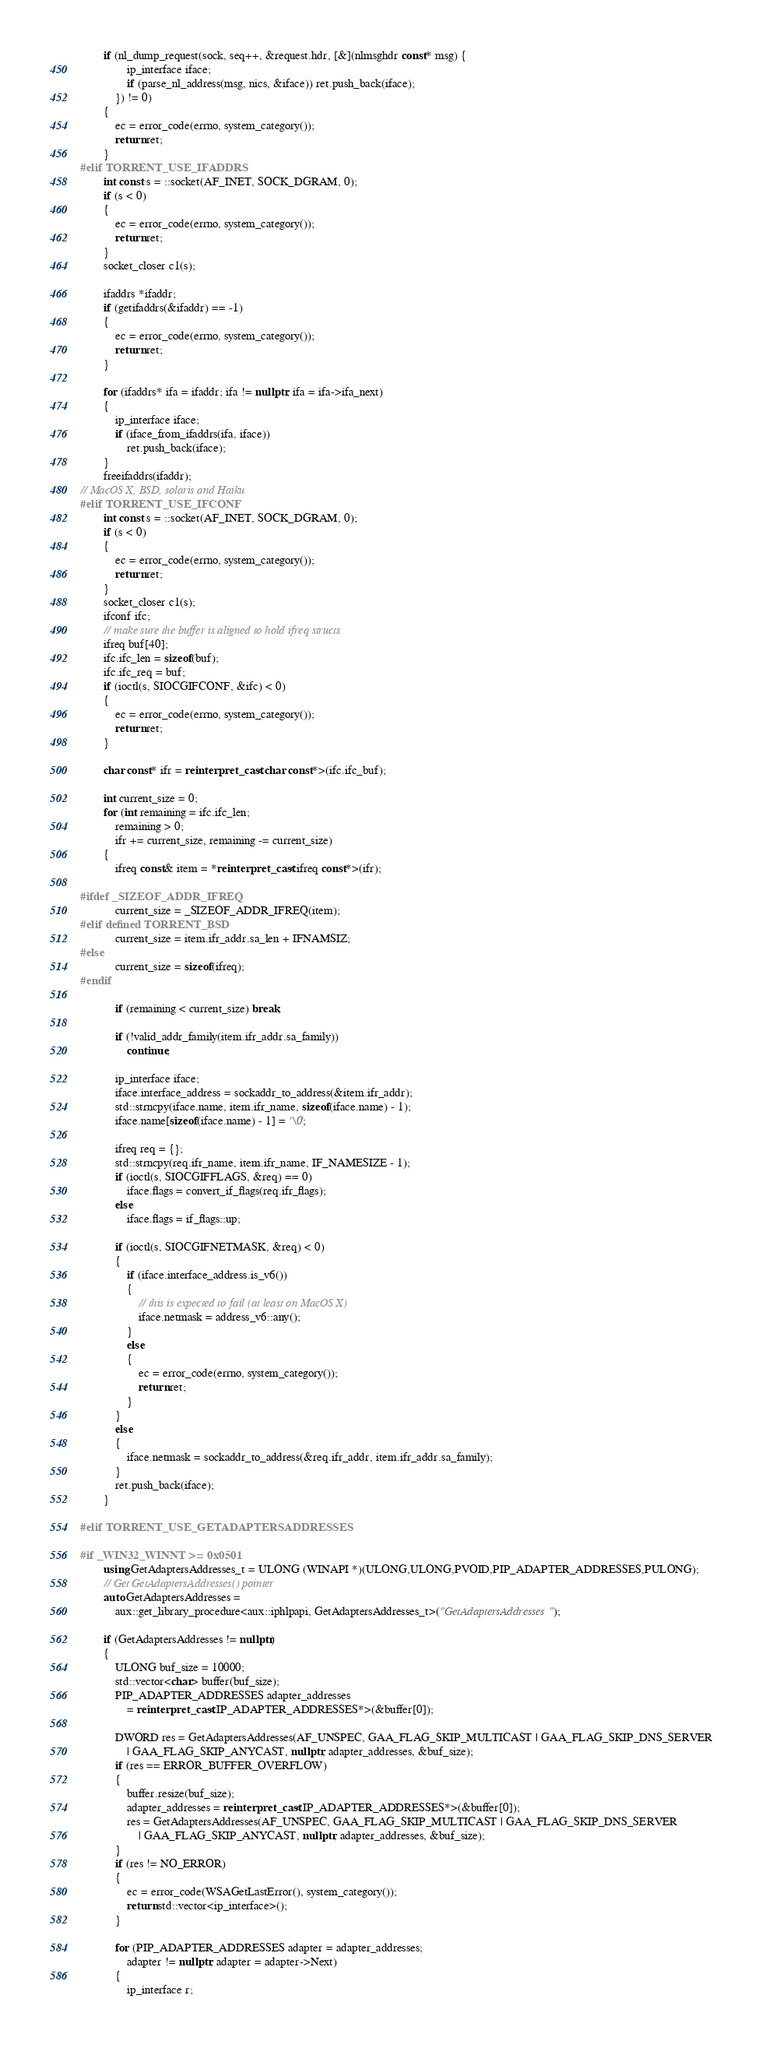Convert code to text. <code><loc_0><loc_0><loc_500><loc_500><_C++_>
		if (nl_dump_request(sock, seq++, &request.hdr, [&](nlmsghdr const* msg) {
				ip_interface iface;
				if (parse_nl_address(msg, nics, &iface)) ret.push_back(iface);
			}) != 0)
		{
			ec = error_code(errno, system_category());
			return ret;
		}
#elif TORRENT_USE_IFADDRS
		int const s = ::socket(AF_INET, SOCK_DGRAM, 0);
		if (s < 0)
		{
			ec = error_code(errno, system_category());
			return ret;
		}
		socket_closer c1(s);

		ifaddrs *ifaddr;
		if (getifaddrs(&ifaddr) == -1)
		{
			ec = error_code(errno, system_category());
			return ret;
		}

		for (ifaddrs* ifa = ifaddr; ifa != nullptr; ifa = ifa->ifa_next)
		{
			ip_interface iface;
			if (iface_from_ifaddrs(ifa, iface))
				ret.push_back(iface);
		}
		freeifaddrs(ifaddr);
// MacOS X, BSD, solaris and Haiku
#elif TORRENT_USE_IFCONF
		int const s = ::socket(AF_INET, SOCK_DGRAM, 0);
		if (s < 0)
		{
			ec = error_code(errno, system_category());
			return ret;
		}
		socket_closer c1(s);
		ifconf ifc;
		// make sure the buffer is aligned to hold ifreq structs
		ifreq buf[40];
		ifc.ifc_len = sizeof(buf);
		ifc.ifc_req = buf;
		if (ioctl(s, SIOCGIFCONF, &ifc) < 0)
		{
			ec = error_code(errno, system_category());
			return ret;
		}

		char const* ifr = reinterpret_cast<char const*>(ifc.ifc_buf);

		int current_size = 0;
		for (int remaining = ifc.ifc_len;
			remaining > 0;
			ifr += current_size, remaining -= current_size)
		{
			ifreq const& item = *reinterpret_cast<ifreq const*>(ifr);

#ifdef _SIZEOF_ADDR_IFREQ
			current_size = _SIZEOF_ADDR_IFREQ(item);
#elif defined TORRENT_BSD
			current_size = item.ifr_addr.sa_len + IFNAMSIZ;
#else
			current_size = sizeof(ifreq);
#endif

			if (remaining < current_size) break;

			if (!valid_addr_family(item.ifr_addr.sa_family))
				continue;

			ip_interface iface;
			iface.interface_address = sockaddr_to_address(&item.ifr_addr);
			std::strncpy(iface.name, item.ifr_name, sizeof(iface.name) - 1);
			iface.name[sizeof(iface.name) - 1] = '\0';

			ifreq req = {};
			std::strncpy(req.ifr_name, item.ifr_name, IF_NAMESIZE - 1);
			if (ioctl(s, SIOCGIFFLAGS, &req) == 0)
				iface.flags = convert_if_flags(req.ifr_flags);
			else
				iface.flags = if_flags::up;

			if (ioctl(s, SIOCGIFNETMASK, &req) < 0)
			{
				if (iface.interface_address.is_v6())
				{
					// this is expected to fail (at least on MacOS X)
					iface.netmask = address_v6::any();
				}
				else
				{
					ec = error_code(errno, system_category());
					return ret;
				}
			}
			else
			{
				iface.netmask = sockaddr_to_address(&req.ifr_addr, item.ifr_addr.sa_family);
			}
			ret.push_back(iface);
		}

#elif TORRENT_USE_GETADAPTERSADDRESSES

#if _WIN32_WINNT >= 0x0501
		using GetAdaptersAddresses_t = ULONG (WINAPI *)(ULONG,ULONG,PVOID,PIP_ADAPTER_ADDRESSES,PULONG);
		// Get GetAdaptersAddresses() pointer
		auto GetAdaptersAddresses =
			aux::get_library_procedure<aux::iphlpapi, GetAdaptersAddresses_t>("GetAdaptersAddresses");

		if (GetAdaptersAddresses != nullptr)
		{
			ULONG buf_size = 10000;
			std::vector<char> buffer(buf_size);
			PIP_ADAPTER_ADDRESSES adapter_addresses
				= reinterpret_cast<IP_ADAPTER_ADDRESSES*>(&buffer[0]);

			DWORD res = GetAdaptersAddresses(AF_UNSPEC, GAA_FLAG_SKIP_MULTICAST | GAA_FLAG_SKIP_DNS_SERVER
				| GAA_FLAG_SKIP_ANYCAST, nullptr, adapter_addresses, &buf_size);
			if (res == ERROR_BUFFER_OVERFLOW)
			{
				buffer.resize(buf_size);
				adapter_addresses = reinterpret_cast<IP_ADAPTER_ADDRESSES*>(&buffer[0]);
				res = GetAdaptersAddresses(AF_UNSPEC, GAA_FLAG_SKIP_MULTICAST | GAA_FLAG_SKIP_DNS_SERVER
					| GAA_FLAG_SKIP_ANYCAST, nullptr, adapter_addresses, &buf_size);
			}
			if (res != NO_ERROR)
			{
				ec = error_code(WSAGetLastError(), system_category());
				return std::vector<ip_interface>();
			}

			for (PIP_ADAPTER_ADDRESSES adapter = adapter_addresses;
				adapter != nullptr; adapter = adapter->Next)
			{
				ip_interface r;</code> 